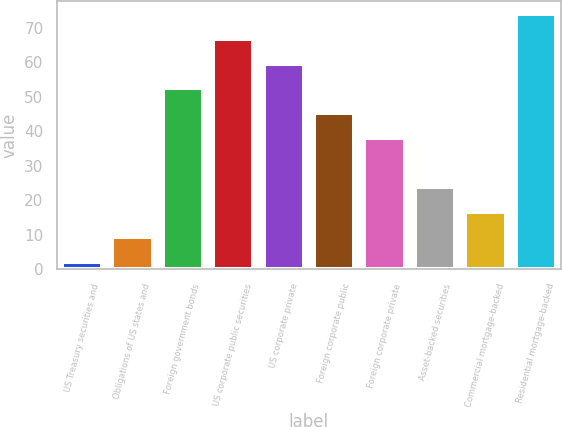<chart> <loc_0><loc_0><loc_500><loc_500><bar_chart><fcel>US Treasury securities and<fcel>Obligations of US states and<fcel>Foreign government bonds<fcel>US corporate public securities<fcel>US corporate private<fcel>Foreign corporate public<fcel>Foreign corporate private<fcel>Asset-backed securities<fcel>Commercial mortgage-backed<fcel>Residential mortgage-backed<nl><fcel>2.2<fcel>9.38<fcel>52.46<fcel>66.82<fcel>59.64<fcel>45.28<fcel>38.1<fcel>23.74<fcel>16.56<fcel>74<nl></chart> 